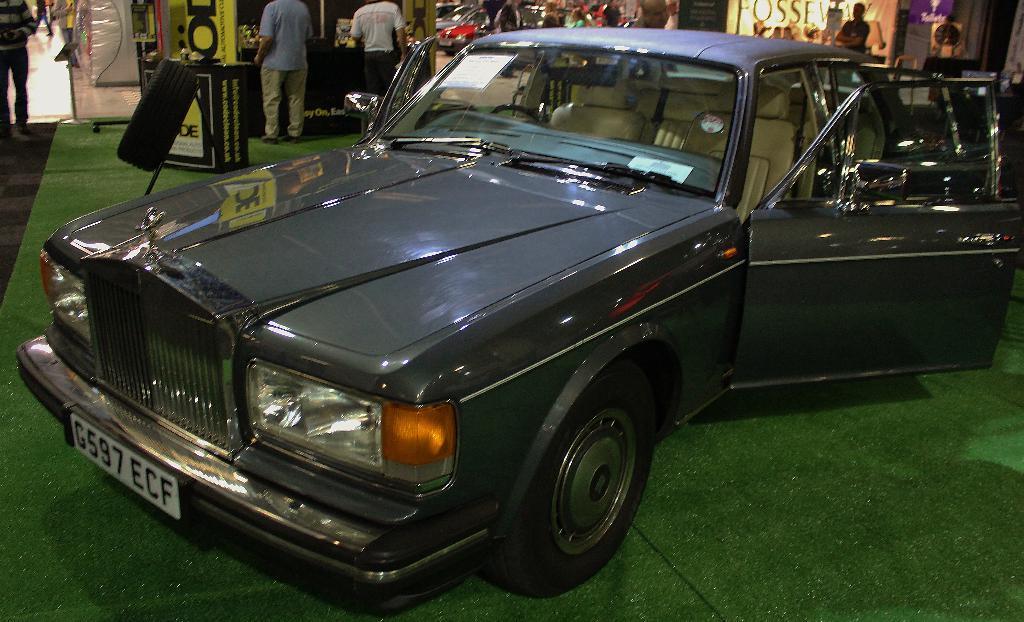Could you give a brief overview of what you see in this image? In this image in the foreground there is a car. In the background there are few shops. Few people are standing in front of the shop. On the ground there is green color carpet. There are boards, banners over here. 